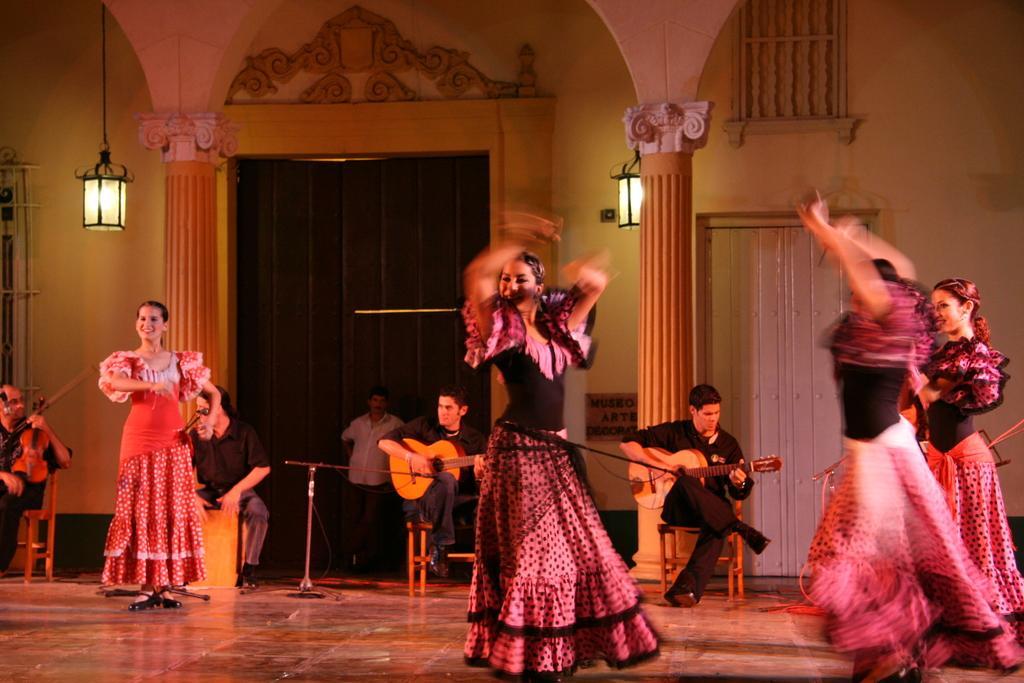Describe this image in one or two sentences. This is the picture taken in a room, on the floor there are group of women are dancing. Behind them there are group of men playing the music instrument and sitting on a chair. Background of these people there are pillar, wall, door and lights. 